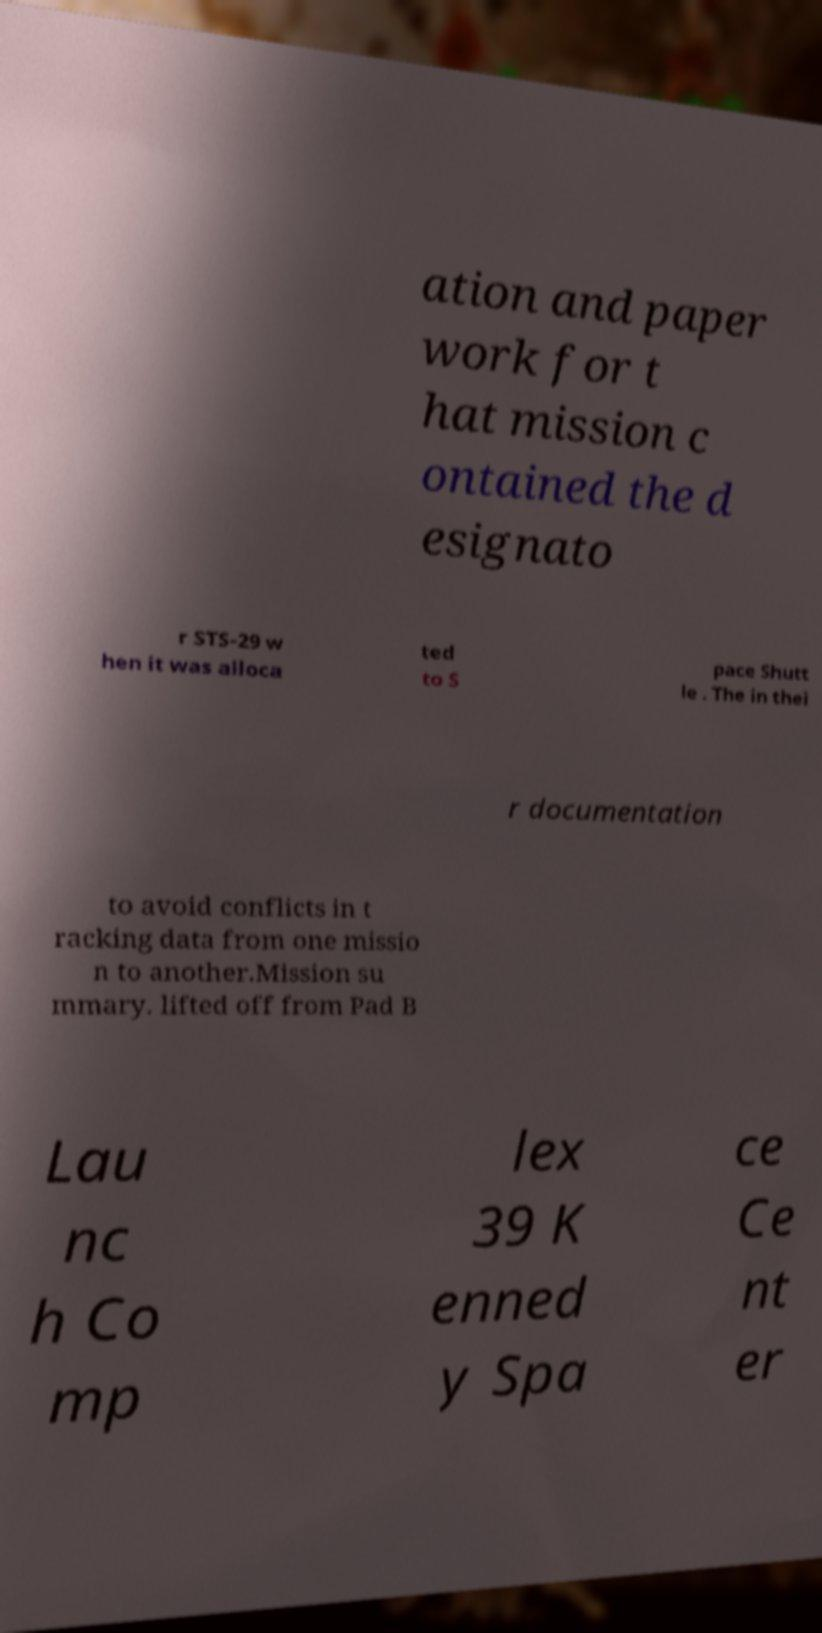Can you accurately transcribe the text from the provided image for me? ation and paper work for t hat mission c ontained the d esignato r STS-29 w hen it was alloca ted to S pace Shutt le . The in thei r documentation to avoid conflicts in t racking data from one missio n to another.Mission su mmary. lifted off from Pad B Lau nc h Co mp lex 39 K enned y Spa ce Ce nt er 